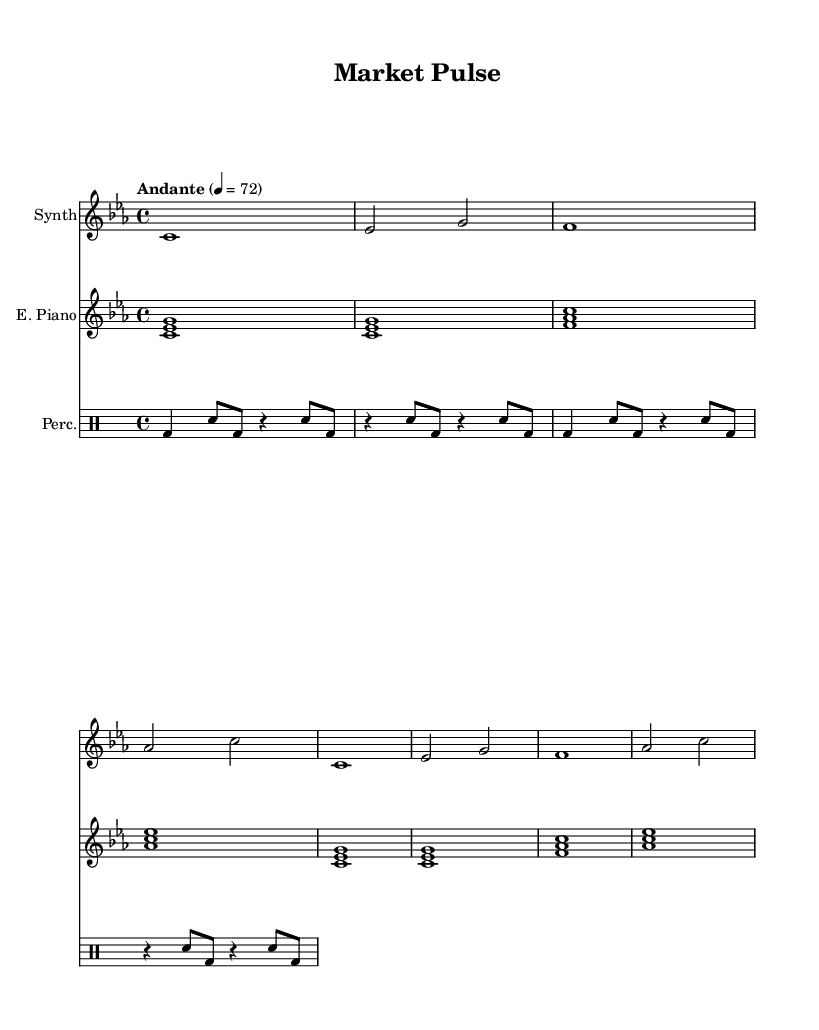What is the key signature of this music? The key signature is C minor, which has three flats (B♭, E♭, and A♭). This can be identified by examining the key signature notation at the beginning of the score.
Answer: C minor What is the time signature of this piece? The time signature is 4/4, which indicates that there are four beats in each measure and the quarter note gets one beat. This information is typically shown at the beginning of the score.
Answer: 4/4 What is the tempo marking for the music? The tempo marking is "Andante," which suggests a moderately slow tempo. This term is often found in the header or marked at the beginning of the score to indicate performance speed.
Answer: Andante How many measures are in the synth part? The synth part contains eight measures, which can be counted by identifying each vertical line (bar line) that separates the measures in the score.
Answer: 8 What are the instruments featured in this score? The featured instruments are Synth, Electric Piano, and Percussion, as indicated in the instrument names above each staff in the score.
Answer: Synth, Electric Piano, Percussion What rhythm pattern is predominantly used in the percussion part? The percussion part predominantly uses a combination of bass drum and snare patterns, which can be observed in the repeated sections of the score. Each measure has a consistent mix of these two types of notes.
Answer: BD and SN pattern Which instrument plays the melody primarily? The Synth instrument plays the melody primarily, as it contains the main pitches in its part, displayed clearly at the top of the score with distinct rhythmic phrases.
Answer: Synth 